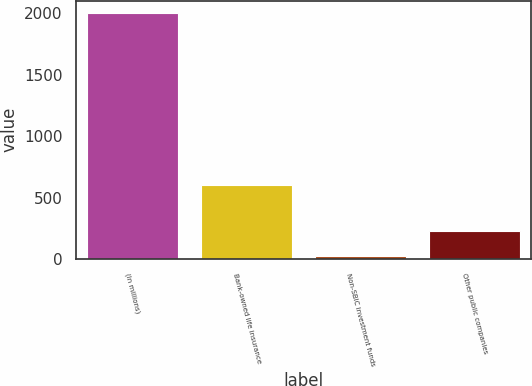<chart> <loc_0><loc_0><loc_500><loc_500><bar_chart><fcel>(In millions)<fcel>Bank-owned life insurance<fcel>Non-SBIC investment funds<fcel>Other public companies<nl><fcel>2005<fcel>605<fcel>27<fcel>224.8<nl></chart> 